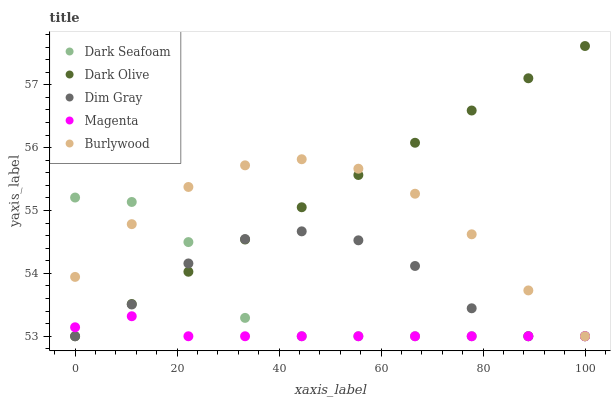Does Magenta have the minimum area under the curve?
Answer yes or no. Yes. Does Dark Olive have the maximum area under the curve?
Answer yes or no. Yes. Does Dark Seafoam have the minimum area under the curve?
Answer yes or no. No. Does Dark Seafoam have the maximum area under the curve?
Answer yes or no. No. Is Dark Olive the smoothest?
Answer yes or no. Yes. Is Dark Seafoam the roughest?
Answer yes or no. Yes. Is Dark Seafoam the smoothest?
Answer yes or no. No. Is Dark Olive the roughest?
Answer yes or no. No. Does Burlywood have the lowest value?
Answer yes or no. Yes. Does Dark Olive have the highest value?
Answer yes or no. Yes. Does Dark Seafoam have the highest value?
Answer yes or no. No. Does Dim Gray intersect Burlywood?
Answer yes or no. Yes. Is Dim Gray less than Burlywood?
Answer yes or no. No. Is Dim Gray greater than Burlywood?
Answer yes or no. No. 